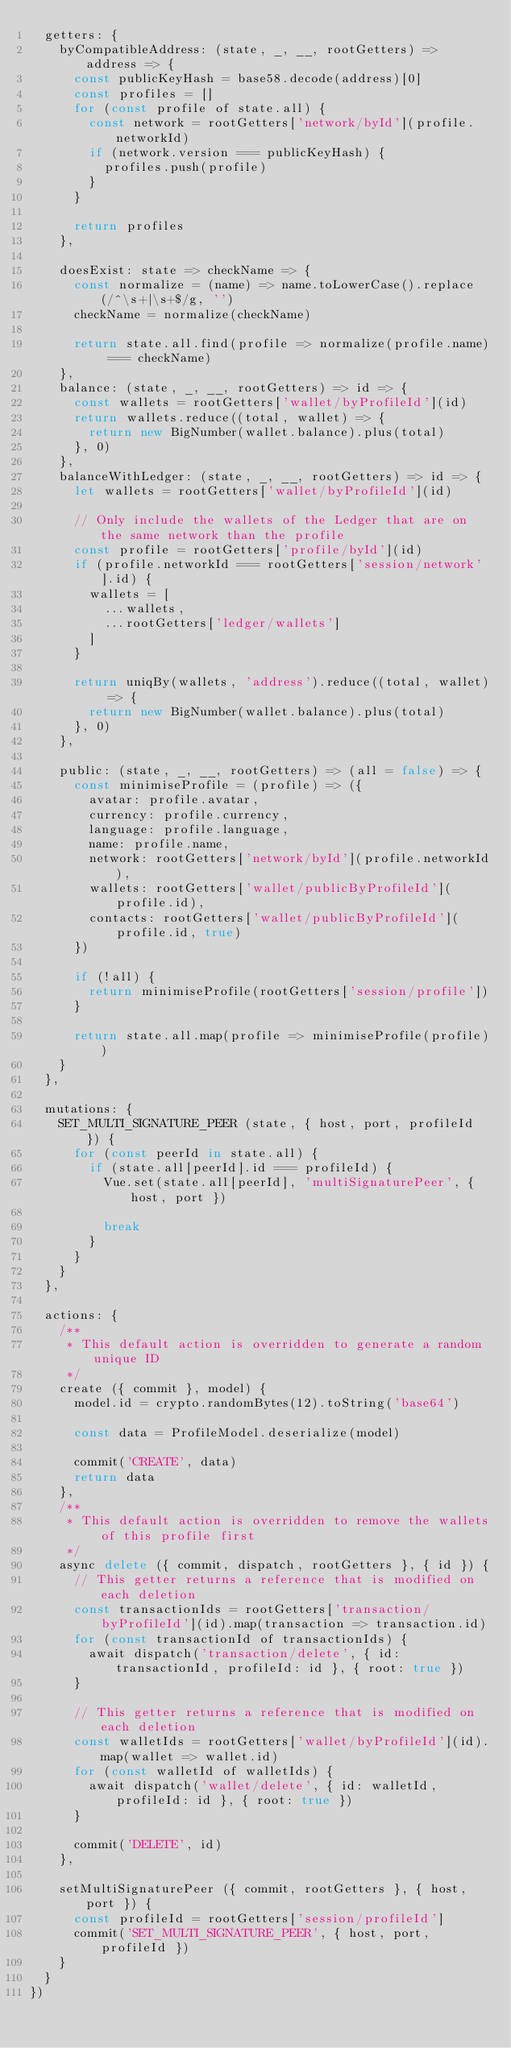<code> <loc_0><loc_0><loc_500><loc_500><_JavaScript_>  getters: {
    byCompatibleAddress: (state, _, __, rootGetters) => address => {
      const publicKeyHash = base58.decode(address)[0]
      const profiles = []
      for (const profile of state.all) {
        const network = rootGetters['network/byId'](profile.networkId)
        if (network.version === publicKeyHash) {
          profiles.push(profile)
        }
      }

      return profiles
    },

    doesExist: state => checkName => {
      const normalize = (name) => name.toLowerCase().replace(/^\s+|\s+$/g, '')
      checkName = normalize(checkName)

      return state.all.find(profile => normalize(profile.name) === checkName)
    },
    balance: (state, _, __, rootGetters) => id => {
      const wallets = rootGetters['wallet/byProfileId'](id)
      return wallets.reduce((total, wallet) => {
        return new BigNumber(wallet.balance).plus(total)
      }, 0)
    },
    balanceWithLedger: (state, _, __, rootGetters) => id => {
      let wallets = rootGetters['wallet/byProfileId'](id)

      // Only include the wallets of the Ledger that are on the same network than the profile
      const profile = rootGetters['profile/byId'](id)
      if (profile.networkId === rootGetters['session/network'].id) {
        wallets = [
          ...wallets,
          ...rootGetters['ledger/wallets']
        ]
      }

      return uniqBy(wallets, 'address').reduce((total, wallet) => {
        return new BigNumber(wallet.balance).plus(total)
      }, 0)
    },

    public: (state, _, __, rootGetters) => (all = false) => {
      const minimiseProfile = (profile) => ({
        avatar: profile.avatar,
        currency: profile.currency,
        language: profile.language,
        name: profile.name,
        network: rootGetters['network/byId'](profile.networkId),
        wallets: rootGetters['wallet/publicByProfileId'](profile.id),
        contacts: rootGetters['wallet/publicByProfileId'](profile.id, true)
      })

      if (!all) {
        return minimiseProfile(rootGetters['session/profile'])
      }

      return state.all.map(profile => minimiseProfile(profile))
    }
  },

  mutations: {
    SET_MULTI_SIGNATURE_PEER (state, { host, port, profileId }) {
      for (const peerId in state.all) {
        if (state.all[peerId].id === profileId) {
          Vue.set(state.all[peerId], 'multiSignaturePeer', { host, port })

          break
        }
      }
    }
  },

  actions: {
    /**
     * This default action is overridden to generate a random unique ID
     */
    create ({ commit }, model) {
      model.id = crypto.randomBytes(12).toString('base64')

      const data = ProfileModel.deserialize(model)

      commit('CREATE', data)
      return data
    },
    /**
     * This default action is overridden to remove the wallets of this profile first
     */
    async delete ({ commit, dispatch, rootGetters }, { id }) {
      // This getter returns a reference that is modified on each deletion
      const transactionIds = rootGetters['transaction/byProfileId'](id).map(transaction => transaction.id)
      for (const transactionId of transactionIds) {
        await dispatch('transaction/delete', { id: transactionId, profileId: id }, { root: true })
      }

      // This getter returns a reference that is modified on each deletion
      const walletIds = rootGetters['wallet/byProfileId'](id).map(wallet => wallet.id)
      for (const walletId of walletIds) {
        await dispatch('wallet/delete', { id: walletId, profileId: id }, { root: true })
      }

      commit('DELETE', id)
    },

    setMultiSignaturePeer ({ commit, rootGetters }, { host, port }) {
      const profileId = rootGetters['session/profileId']
      commit('SET_MULTI_SIGNATURE_PEER', { host, port, profileId })
    }
  }
})
</code> 